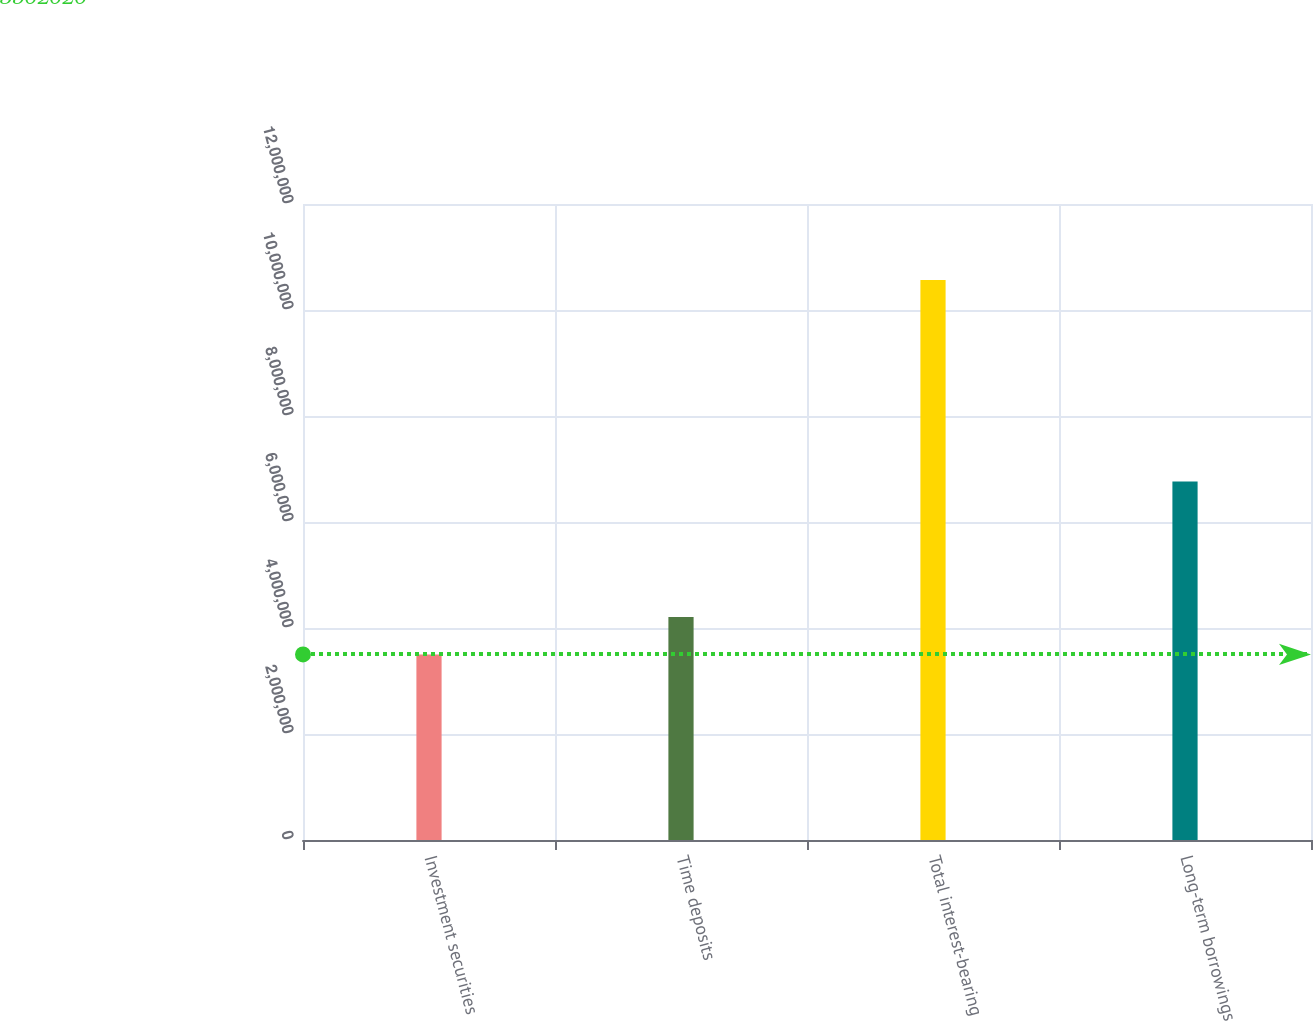Convert chart. <chart><loc_0><loc_0><loc_500><loc_500><bar_chart><fcel>Investment securities<fcel>Time deposits<fcel>Total interest-bearing<fcel>Long-term borrowings<nl><fcel>3.50202e+06<fcel>4.20863e+06<fcel>1.05681e+07<fcel>6.76605e+06<nl></chart> 